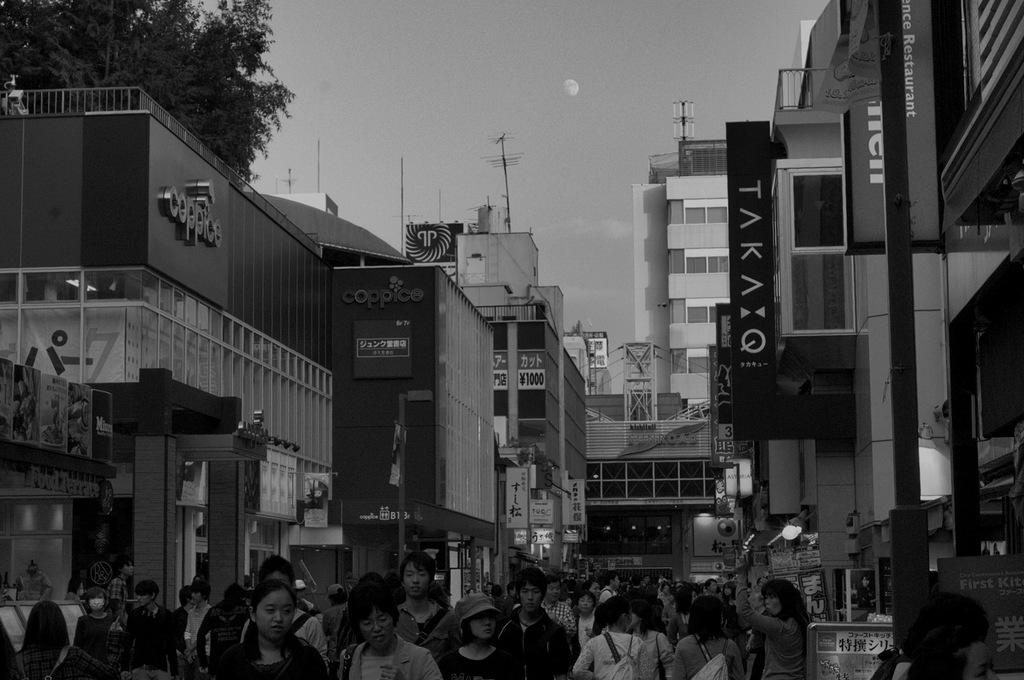What type of structures can be seen in the image? There are buildings in the image. What objects are present in the image besides the buildings? There are boards and a tree visible in the image. How many people are at the bottom of the image? There are many people at the bottom of the image. What is visible at the top of the image? The sky is visible at the top of the image. What type of wound can be seen on the flag in the image? There is no flag present in the image, so it is not possible to determine if there is a wound on it. 